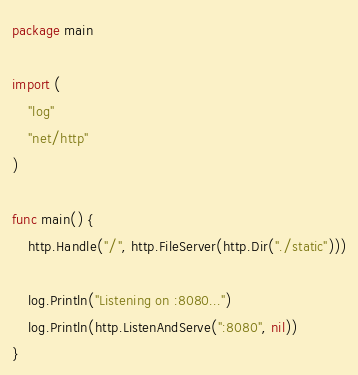<code> <loc_0><loc_0><loc_500><loc_500><_Go_>package main

import (
	"log"
	"net/http"
)

func main() {
	http.Handle("/", http.FileServer(http.Dir("./static")))

	log.Println("Listening on :8080...")
	log.Println(http.ListenAndServe(":8080", nil))
}
</code> 